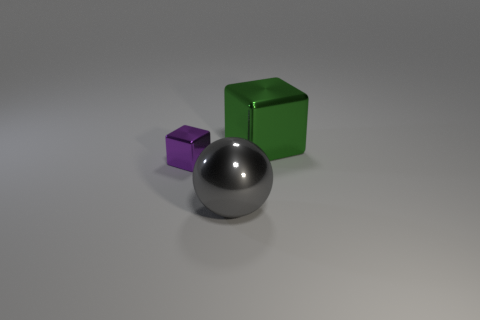Add 3 large metal spheres. How many objects exist? 6 Subtract all blocks. How many objects are left? 1 Subtract 0 yellow cylinders. How many objects are left? 3 Subtract all big red cylinders. Subtract all green metal things. How many objects are left? 2 Add 1 large gray spheres. How many large gray spheres are left? 2 Add 3 big metallic balls. How many big metallic balls exist? 4 